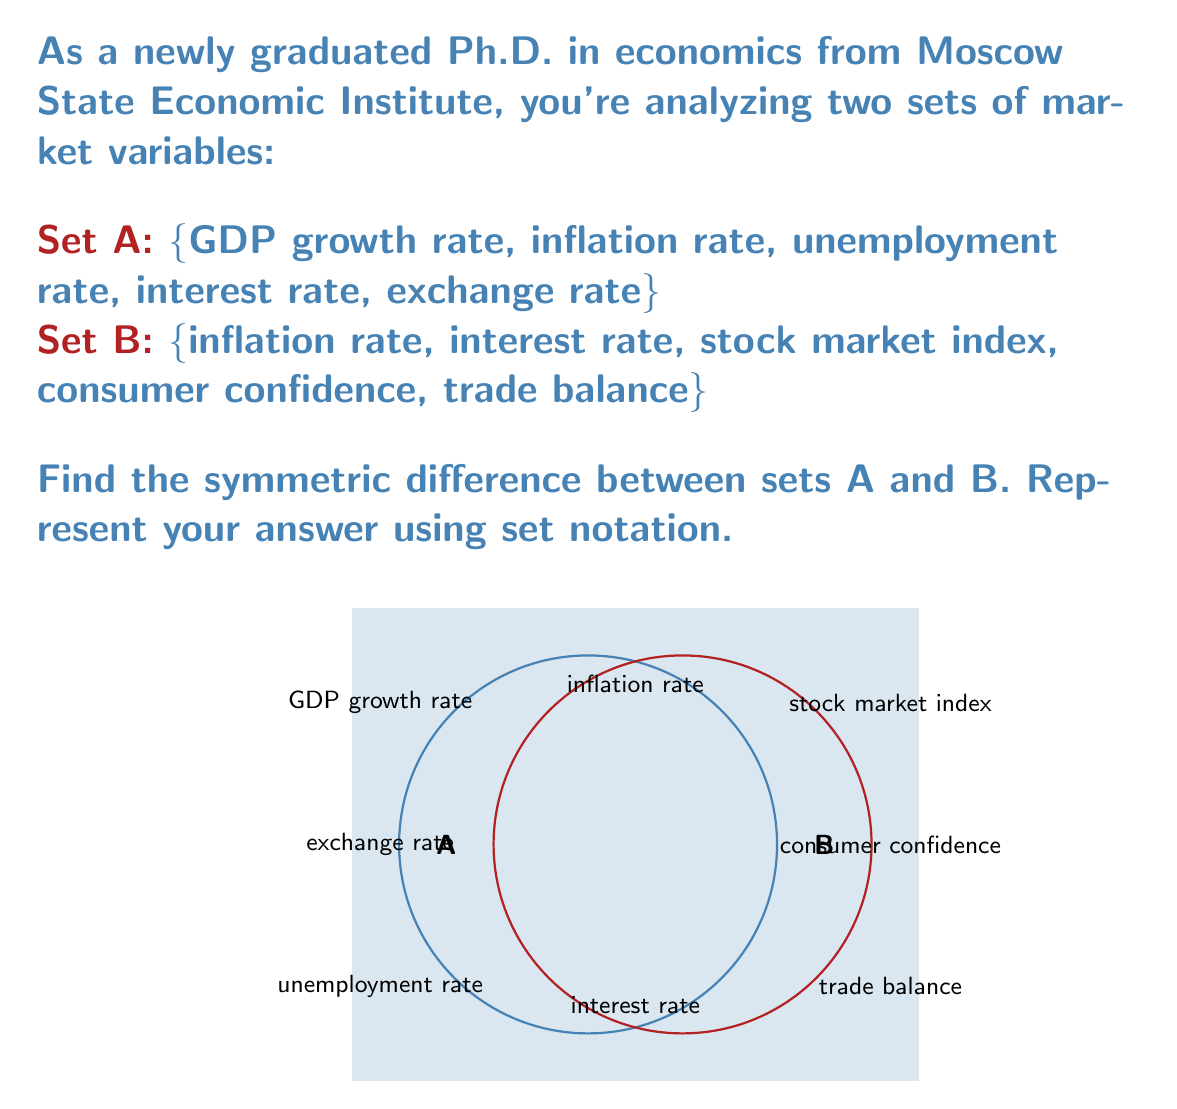Teach me how to tackle this problem. To find the symmetric difference between two sets, we need to follow these steps:

1) Recall the definition of symmetric difference:
   The symmetric difference of sets A and B, denoted as $A \triangle B$, is the set of elements that are in either A or B, but not in both.

2) Mathematically, this can be expressed as:
   $A \triangle B = (A \setminus B) \cup (B \setminus A)$

3) Let's identify the elements in each set:
   A = {GDP growth rate, inflation rate, unemployment rate, interest rate, exchange rate}
   B = {inflation rate, interest rate, stock market index, consumer confidence, trade balance}

4) Find $A \setminus B$ (elements in A but not in B):
   A \setminus B = {GDP growth rate, unemployment rate, exchange rate}

5) Find $B \setminus A$ (elements in B but not in A):
   B \setminus A = {stock market index, consumer confidence, trade balance}

6) Now, we take the union of these two sets:
   $(A \setminus B) \cup (B \setminus A)$ = {GDP growth rate, unemployment rate, exchange rate, stock market index, consumer confidence, trade balance}

This set represents the symmetric difference between A and B.
Answer: $A \triangle B = \text{\{GDP growth rate, unemployment rate, exchange rate, stock market index, consumer confidence, trade balance\}}$ 